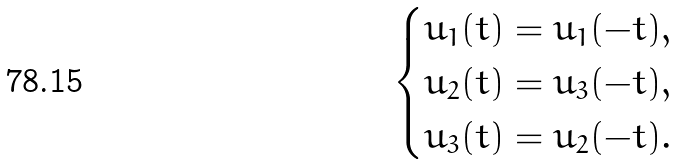<formula> <loc_0><loc_0><loc_500><loc_500>\begin{cases} u _ { 1 } ( t ) = u _ { 1 } ( - t ) , \\ u _ { 2 } ( t ) = u _ { 3 } ( - t ) , \\ u _ { 3 } ( t ) = u _ { 2 } ( - t ) . \end{cases}</formula> 